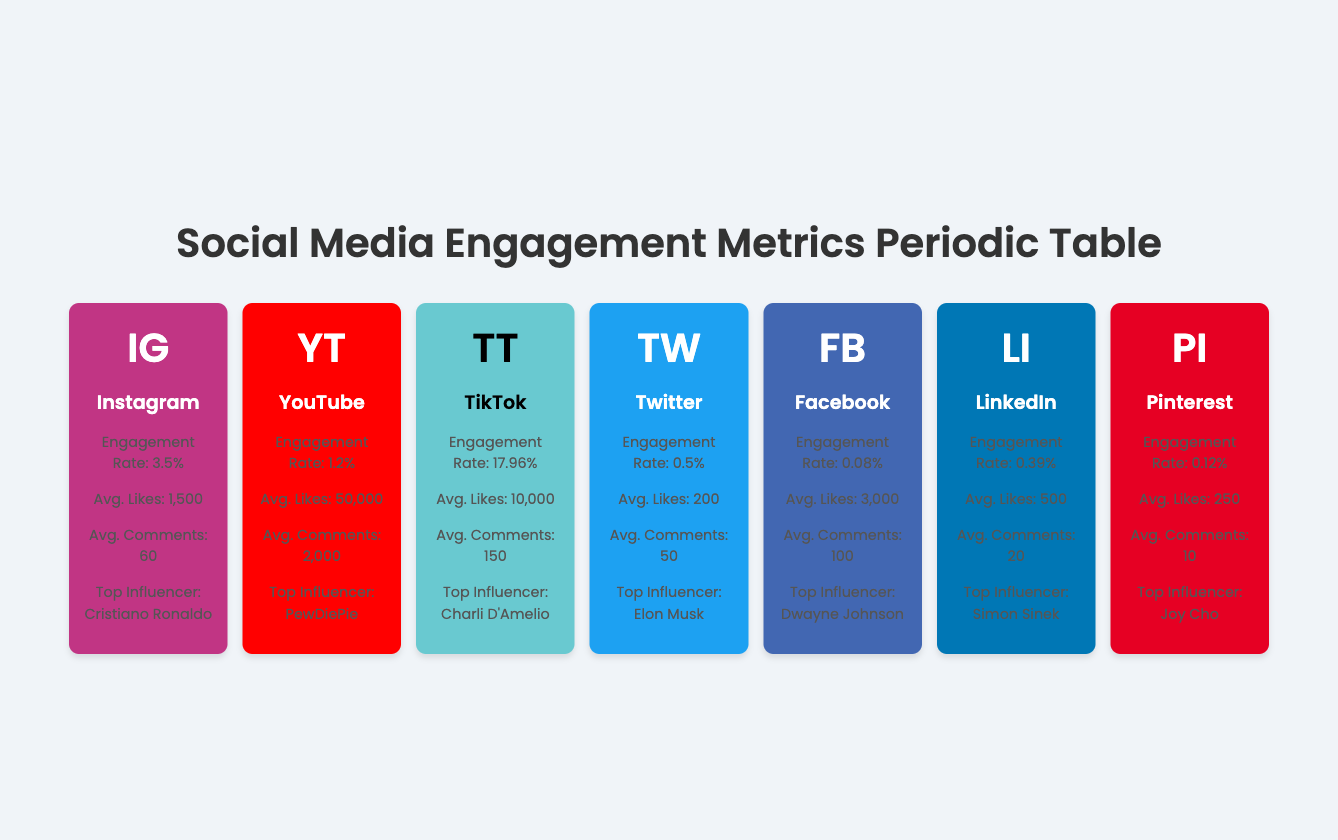What is the engagement rate for TikTok? The table contains a specific engagement rate for each platform listed. By locating the TikTok entry in the table, we can directly identify its engagement rate. The entry indicates that the engagement rate for TikTok is 17.96%.
Answer: 17.96% Which platform has the highest average likes? To determine which platform has the highest average likes, we compare the average likes across all listed platforms. By scanning through the values, we find that YouTube has the highest average likes at 50,000.
Answer: YouTube What is the average engagement rate of Instagram and Facebook? The engagement rate for Instagram is 3.5% and for Facebook, it is 0.08%. To find the average, we calculate (3.5 + 0.08) / 2 = 1.79%. This shows that the average engagement rate of these two platforms is 1.79%.
Answer: 1.79% Is the average number of comments on YouTube greater than on LinkedIn? The average number of comments for YouTube is 2,000 and for LinkedIn, it is 20. Since 2,000 is greater than 20, this statement is true.
Answer: Yes What is the difference in average likes between Instagram and Twitter? The average likes for Instagram is 1,500, while for Twitter it is 200. To calculate the difference, we subtract Twitter's likes from Instagram's: 1,500 - 200 = 1,300.
Answer: 1,300 How many platforms have an engagement rate below 1%? By examining the engagement rates listed in the table, we find Facebook (0.08%), Twitter (0.5%), and LinkedIn (0.39%) have engagement rates below 1%. This totals three platforms.
Answer: 3 Which influencer has the highest number of average comments? The average comments for each platform are: Instagram (60), YouTube (2,000), TikTok (150), Twitter (50), Facebook (100), LinkedIn (20), and Pinterest (10). The highest average comments are found on YouTube with 2,000.
Answer: YouTube Is there a notable metric highlighting the use of stories for Instagram? The notable metric for Instagram mentions engagement is primarily through stories and posts, which confirms the statement. Therefore, it is true.
Answer: Yes What is the total number of followers range across all platforms? The follower ranges are: Instagram (10k - 10M), YouTube (1k - 100M), TikTok (1k - 200M), Twitter (1k - 100M), Facebook (10k - 100M), LinkedIn (500 - 15M), and Pinterest (1k - 10M). Listing them does not provide a simple total but indicates a wide range of potential followers across platforms.
Answer: N/A (the answer is not a single number) 